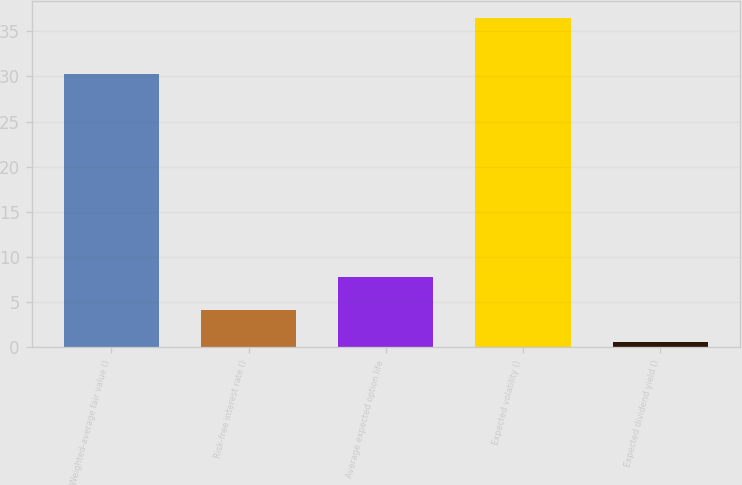<chart> <loc_0><loc_0><loc_500><loc_500><bar_chart><fcel>Weighted-average fair value ()<fcel>Risk-free interest rate ()<fcel>Average expected option life<fcel>Expected volatility ()<fcel>Expected dividend yield ()<nl><fcel>30.25<fcel>4.17<fcel>7.76<fcel>36.51<fcel>0.58<nl></chart> 